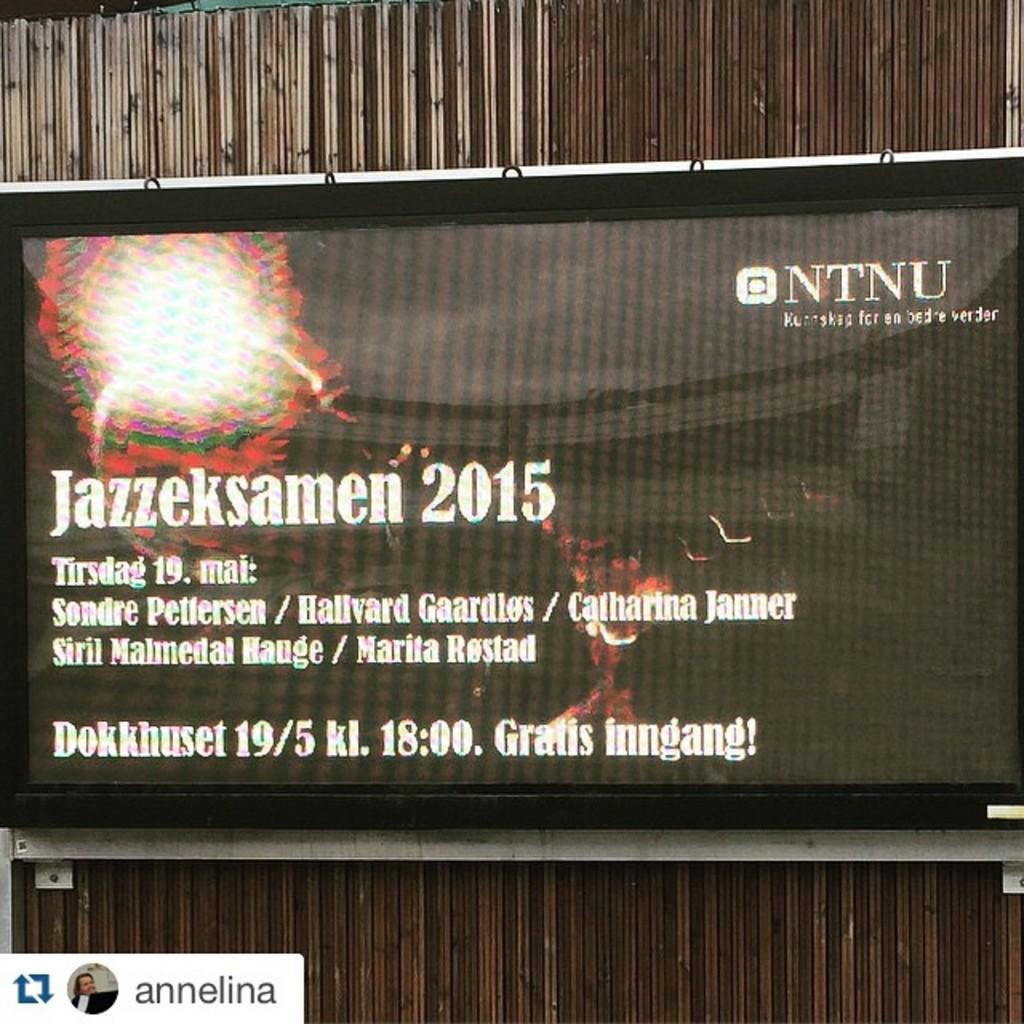What year is this ad from?
Offer a very short reply. 2015. What is the upper right hand company logo?
Provide a succinct answer. Ntnu. 